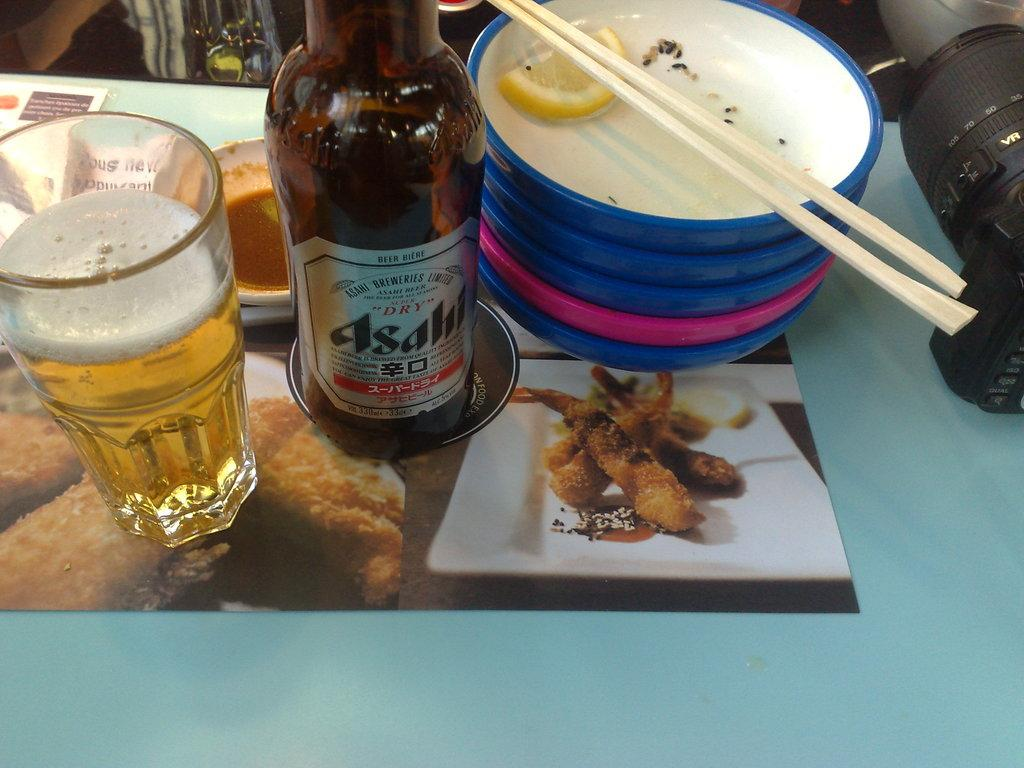What type of beverage container is in the image? There is a wine bottle in the image. What is the wine bottle's contents being used for? The wine is being poured into a glass, which is also visible in the image. What other items can be seen on the table? There are plates and a pair of chopsticks in the image. What device is used to capture images in the scene? There is a camera in the image. What type of wood is the yoke made of in the image? There is no yoke present in the image. How many mice are visible in the image? There are no mice present in the image. 